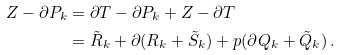<formula> <loc_0><loc_0><loc_500><loc_500>Z - \partial P _ { k } & = \partial T - \partial P _ { k } + Z - \partial T \\ & = \tilde { R } _ { k } + \partial ( R _ { k } + \tilde { S } _ { k } ) + p ( \partial Q _ { k } + \tilde { Q } _ { k } ) \, .</formula> 